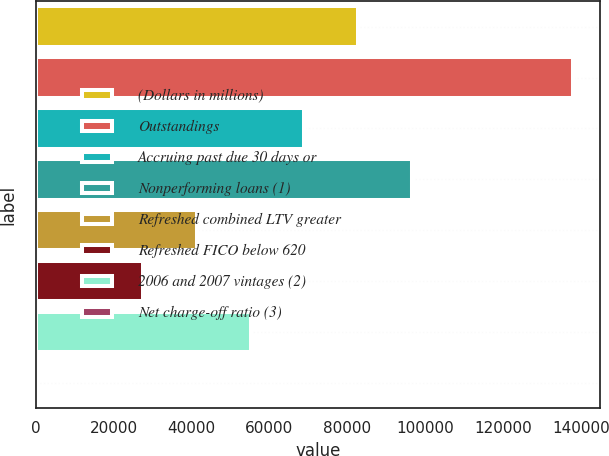Convert chart. <chart><loc_0><loc_0><loc_500><loc_500><bar_chart><fcel>(Dollars in millions)<fcel>Outstandings<fcel>Accruing past due 30 days or<fcel>Nonperforming loans (1)<fcel>Refreshed combined LTV greater<fcel>Refreshed FICO below 620<fcel>2006 and 2007 vintages (2)<fcel>Net charge-off ratio (3)<nl><fcel>82790.5<fcel>137981<fcel>68992.9<fcel>96588.1<fcel>41397.6<fcel>27599.9<fcel>55195.2<fcel>4.65<nl></chart> 